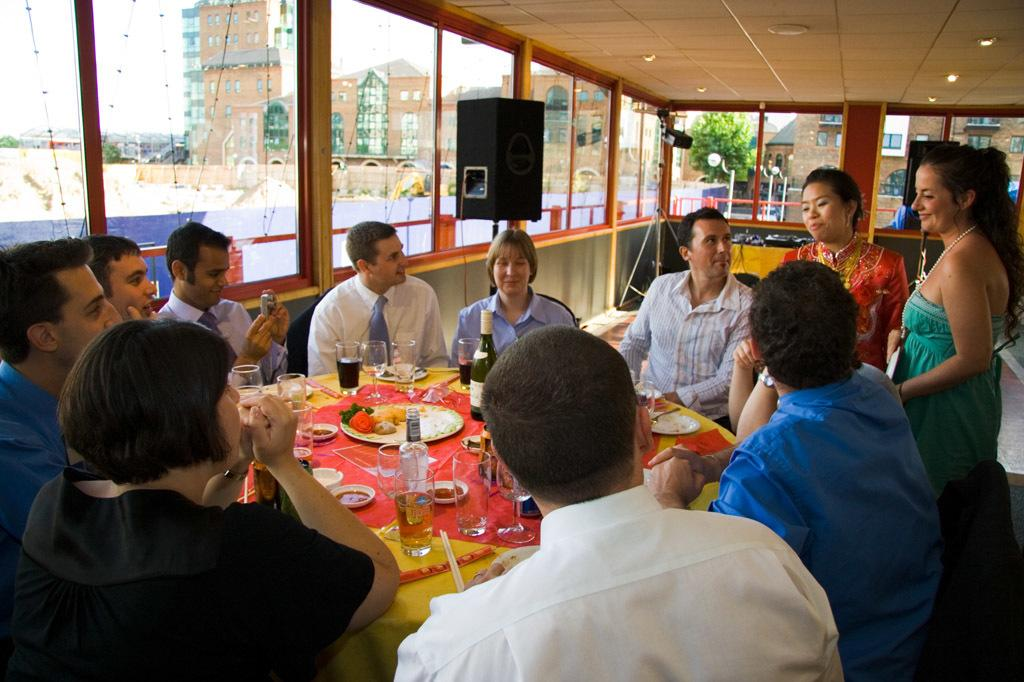How many people are in the image? There is a group of people in the image, but the exact number is not specified. What are the people doing in the image? The group of people is gathered around a table. What can be seen on the table in the image? There is a wine bottle, beverage glasses, and a plate with food on the table. What is visible in the background of the image? There is a window in the background of the image. What type of discussion is taking place around the table in the image? There is no indication of a discussion taking place in the image; it only shows a group of people gathered around a table with various items. Can you see a stream flowing through the window in the image? There is no stream visible through the window in the image; only the window itself is mentioned. 